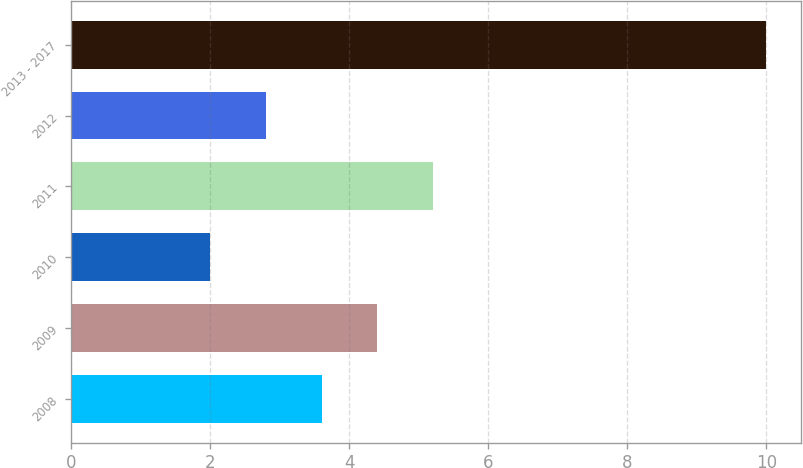Convert chart to OTSL. <chart><loc_0><loc_0><loc_500><loc_500><bar_chart><fcel>2008<fcel>2009<fcel>2010<fcel>2011<fcel>2012<fcel>2013 - 2017<nl><fcel>3.6<fcel>4.4<fcel>2<fcel>5.2<fcel>2.8<fcel>10<nl></chart> 